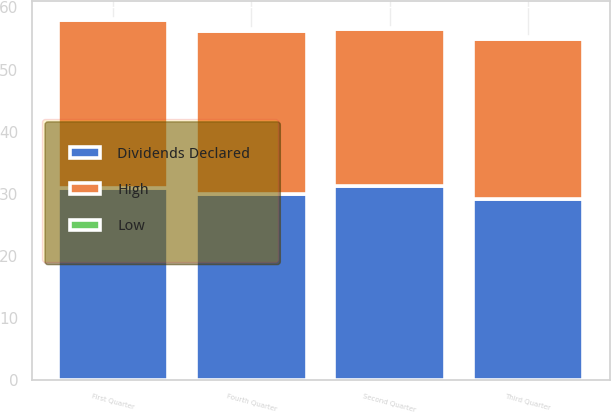Convert chart to OTSL. <chart><loc_0><loc_0><loc_500><loc_500><stacked_bar_chart><ecel><fcel>First Quarter<fcel>Second Quarter<fcel>Third Quarter<fcel>Fourth Quarter<nl><fcel>Dividends Declared<fcel>30.92<fcel>31.32<fcel>29.22<fcel>29.97<nl><fcel>High<fcel>27<fcel>25.15<fcel>25.76<fcel>26.25<nl><fcel>Low<fcel>0.22<fcel>0.22<fcel>0.23<fcel>0.23<nl></chart> 